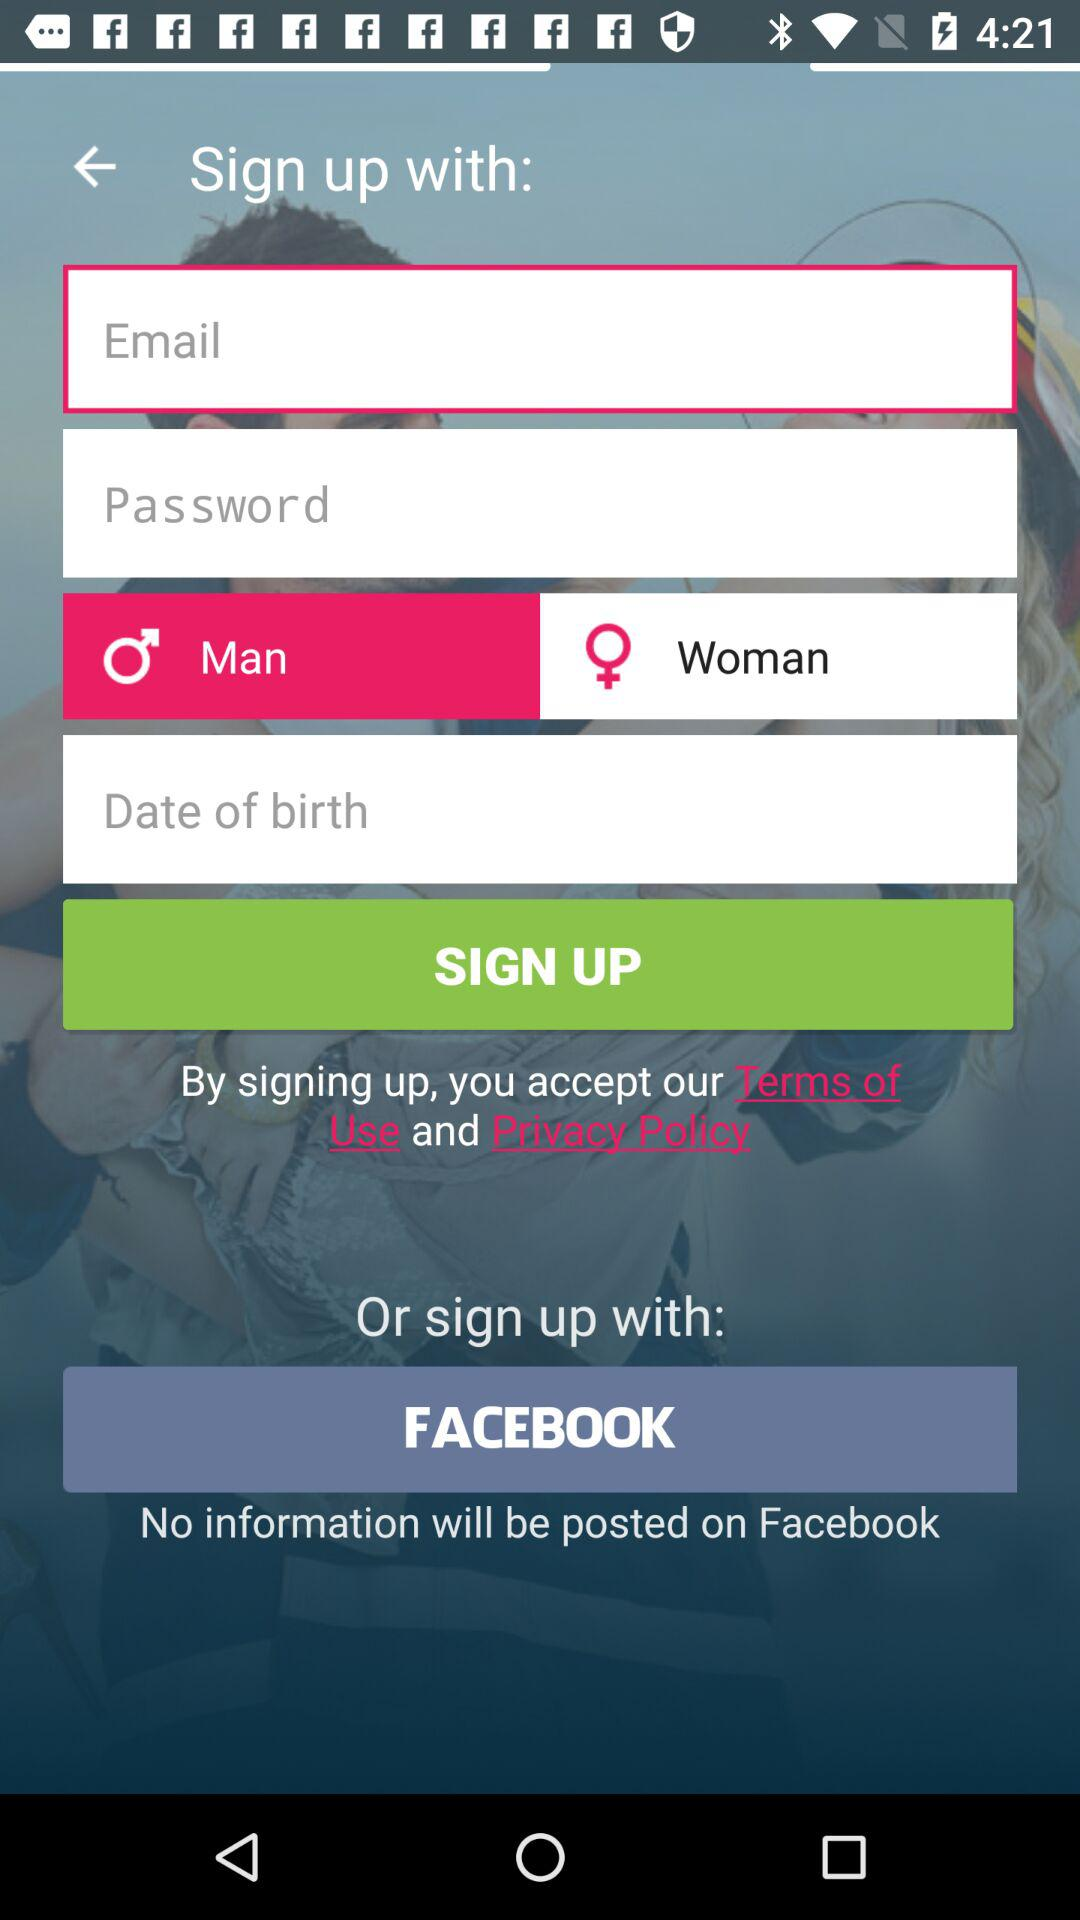How many fields are there for signing up?
Answer the question using a single word or phrase. 4 